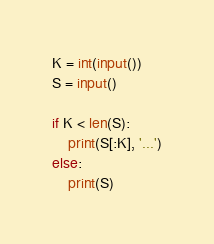<code> <loc_0><loc_0><loc_500><loc_500><_Python_>K = int(input())
S = input()

if K < len(S):
    print(S[:K], '...')
else:
    print(S)</code> 